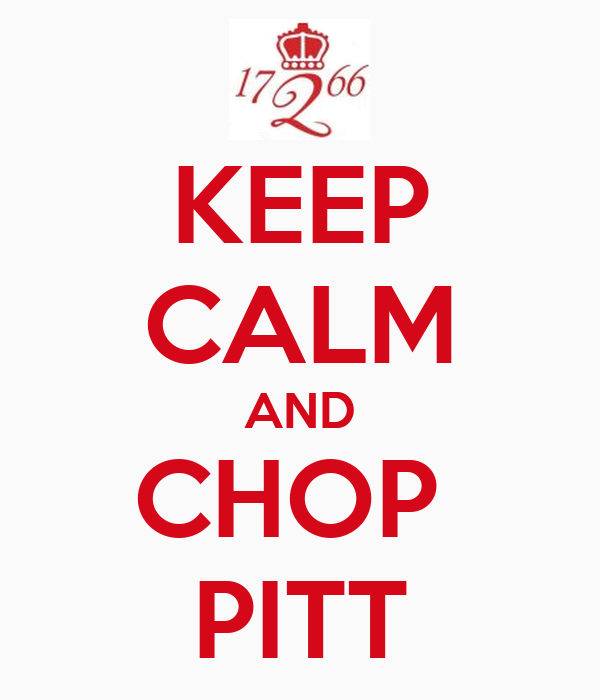What emotions does this image aim to evoke based on its design elements and text? The image aims to evoke a sense of calm and determination. Taking inspiration from the classic 'Keep Calm and Carry On' poster, it utilizes the sharegpt4v/same reassuring, authoritative tone. The phrase 'Keep Calm and Chop Pitt' seeks to instill a resolute attitude, encouraging viewers to act with composure and decisiveness, possibly in the face of a challenge or competition. The red color scheme adds a sense of urgency and power to the message. 